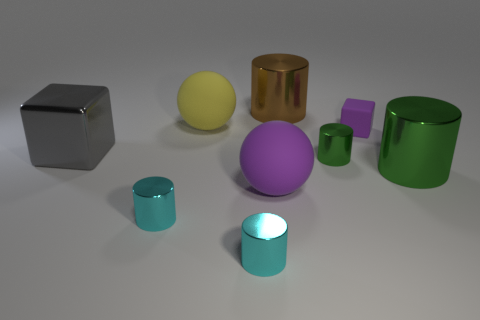What number of things are either large objects in front of the brown metal thing or metal cylinders that are in front of the large metallic cube?
Keep it short and to the point. 7. What number of other objects are there of the same size as the brown shiny object?
Your response must be concise. 4. Is the color of the large rubber thing that is in front of the large gray block the same as the rubber block?
Make the answer very short. Yes. There is a matte thing that is both right of the yellow object and behind the purple rubber sphere; what size is it?
Your response must be concise. Small. How many big objects are yellow rubber objects or blue matte balls?
Provide a succinct answer. 1. What is the shape of the tiny green metallic object behind the large purple rubber ball?
Provide a short and direct response. Cylinder. How many tiny metallic things are there?
Your response must be concise. 3. Is the material of the purple cube the same as the tiny green cylinder?
Offer a very short reply. No. Is the number of gray metal blocks that are behind the big brown metallic cylinder greater than the number of big yellow matte blocks?
Your response must be concise. No. How many things are either big brown objects or objects that are on the right side of the gray thing?
Your response must be concise. 8. 